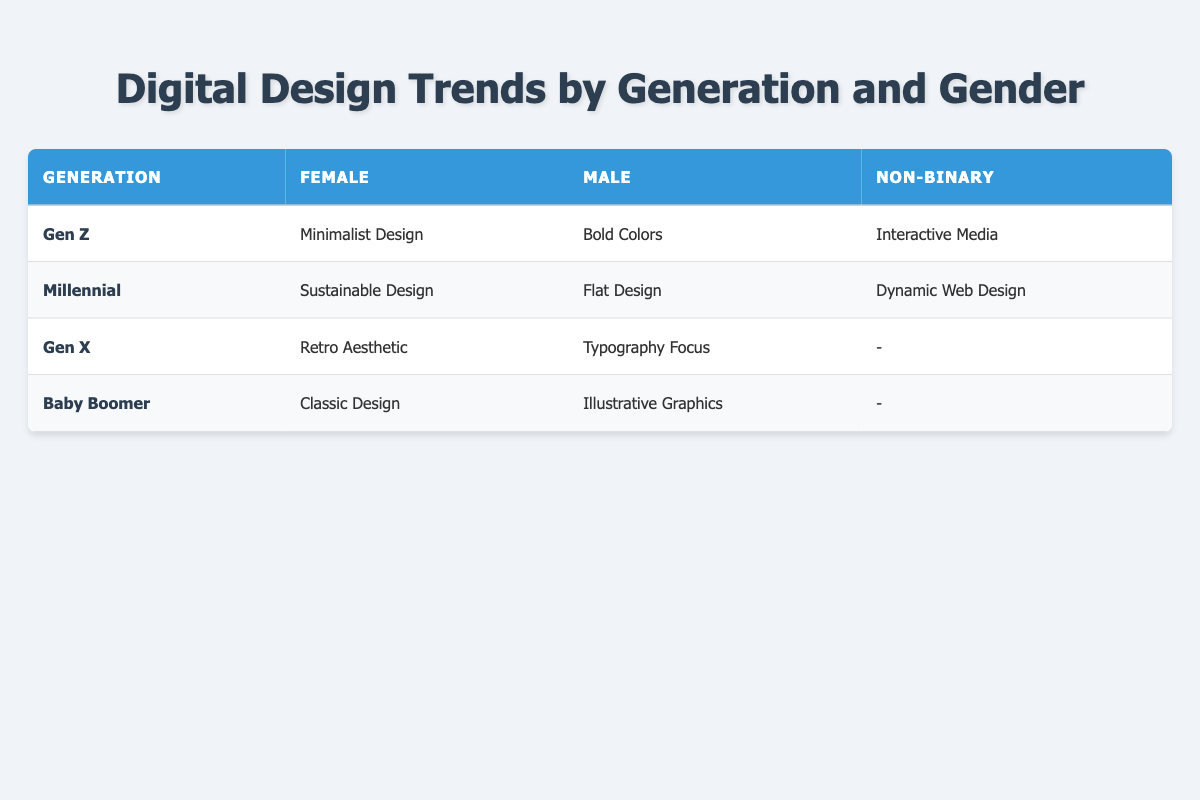What is the design preference for Millennial males? According to the table, the design preference for Millennial males is Flat Design, as it is specified in the "Male" column under the "Millennial" row.
Answer: Flat Design Which generation prefers Interactive Media? The table indicates that Interactive Media is the preference of Non-binary individuals from Gen Z, as shown in the "Non-binary" column under the "Gen Z" row.
Answer: Gen Z Are there any design preferences listed for Non-binary individuals in Gen X? The table shows that there is no design preference listed for Non-binary individuals in Gen X, indicated by a "-" in the "Non-binary" column under the "Gen X" row.
Answer: No What are the preferences of female Baby Boomers and male Gen Z combined? To find this, we take the female preference for Baby Boomers, which is Classic Design, and combine it with the male preference for Gen Z, which is Bold Colors. Thus, the combined preferences are Classic Design and Bold Colors.
Answer: Classic Design and Bold Colors How many unique preferences are there for Millennials? Looking through the table, Millennials have three distinct preferences: Sustainable Design for females, Flat Design for males, and Dynamic Web Design for Non-binary individuals. Adding these, we have three unique preferences in total.
Answer: 3 